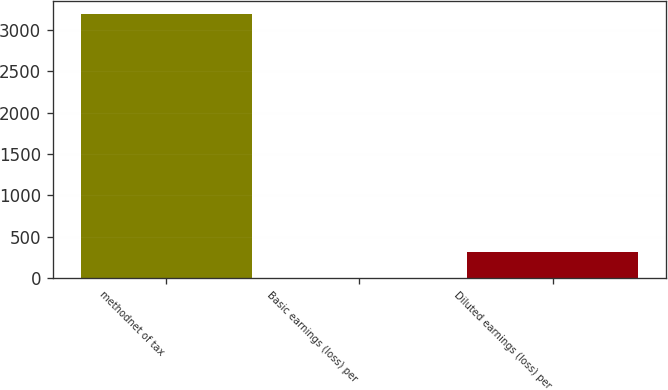Convert chart. <chart><loc_0><loc_0><loc_500><loc_500><bar_chart><fcel>methodnet of tax<fcel>Basic earnings (loss) per<fcel>Diluted earnings (loss) per<nl><fcel>3194<fcel>0.17<fcel>319.55<nl></chart> 